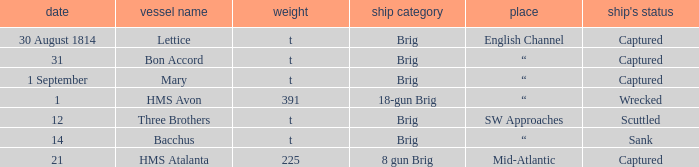Where was the ship when the ship had captured as the disposition of ship and was carrying 225 tonnage? Mid-Atlantic. 